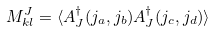Convert formula to latex. <formula><loc_0><loc_0><loc_500><loc_500>M ^ { J } _ { k l } = \langle A _ { J } ^ { \dagger } ( j _ { a } , j _ { b } ) A _ { J } ^ { \dagger } ( j _ { c } , j _ { d } ) \rangle \,</formula> 